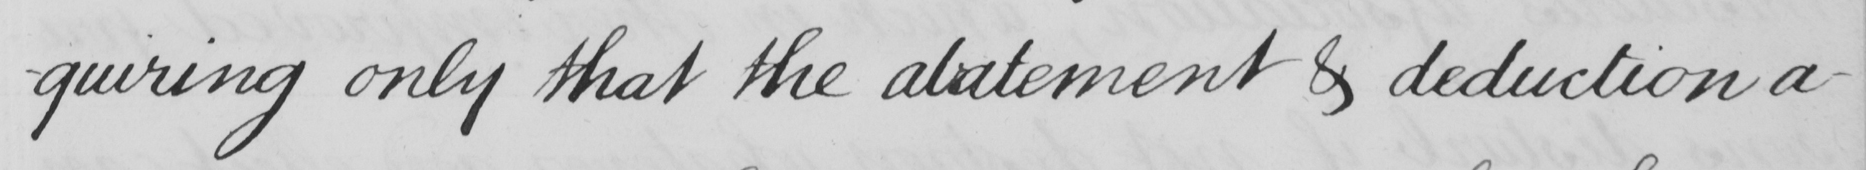Can you read and transcribe this handwriting? -quiring only that the abatement & deduction a- 